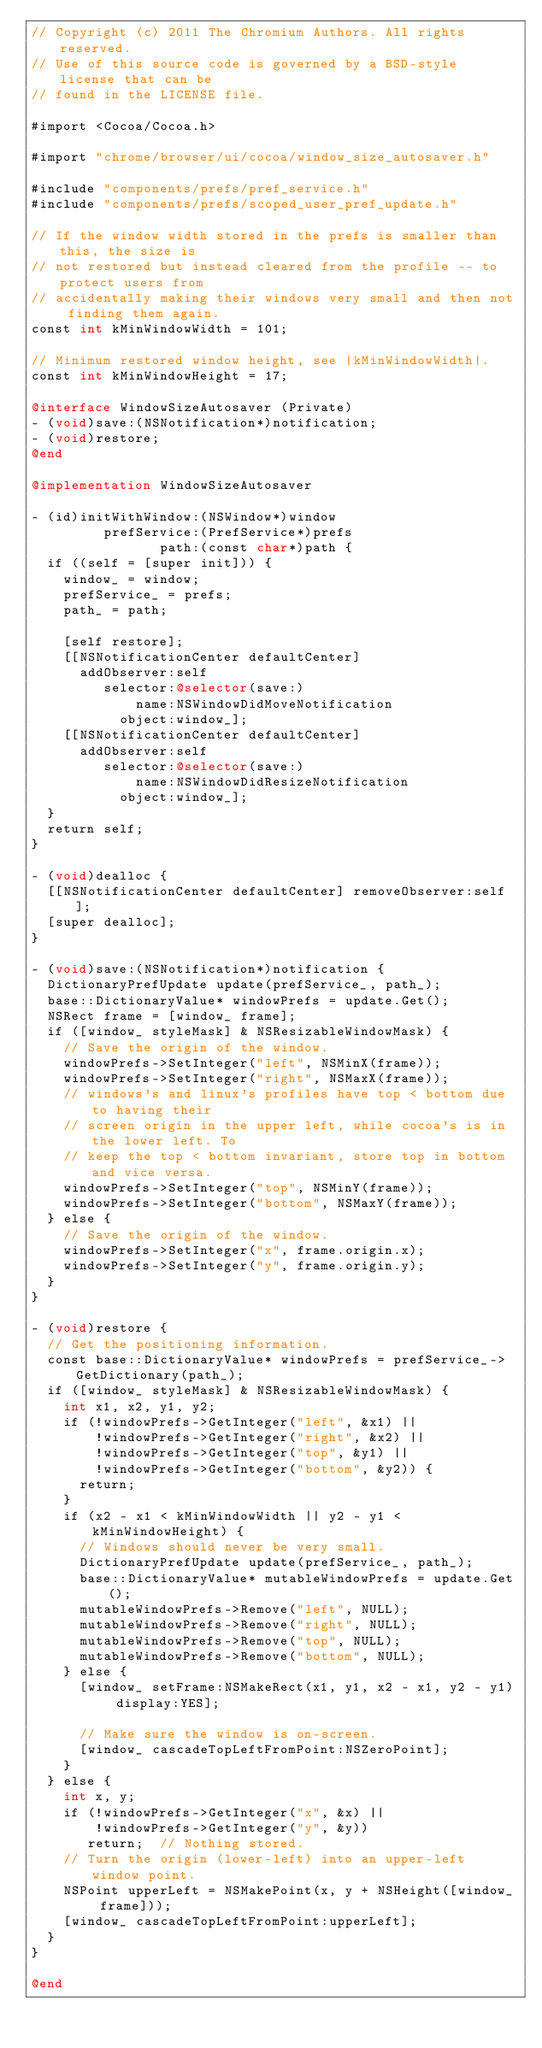<code> <loc_0><loc_0><loc_500><loc_500><_ObjectiveC_>// Copyright (c) 2011 The Chromium Authors. All rights reserved.
// Use of this source code is governed by a BSD-style license that can be
// found in the LICENSE file.

#import <Cocoa/Cocoa.h>

#import "chrome/browser/ui/cocoa/window_size_autosaver.h"

#include "components/prefs/pref_service.h"
#include "components/prefs/scoped_user_pref_update.h"

// If the window width stored in the prefs is smaller than this, the size is
// not restored but instead cleared from the profile -- to protect users from
// accidentally making their windows very small and then not finding them again.
const int kMinWindowWidth = 101;

// Minimum restored window height, see |kMinWindowWidth|.
const int kMinWindowHeight = 17;

@interface WindowSizeAutosaver (Private)
- (void)save:(NSNotification*)notification;
- (void)restore;
@end

@implementation WindowSizeAutosaver

- (id)initWithWindow:(NSWindow*)window
         prefService:(PrefService*)prefs
                path:(const char*)path {
  if ((self = [super init])) {
    window_ = window;
    prefService_ = prefs;
    path_ = path;

    [self restore];
    [[NSNotificationCenter defaultCenter]
      addObserver:self
         selector:@selector(save:)
             name:NSWindowDidMoveNotification
           object:window_];
    [[NSNotificationCenter defaultCenter]
      addObserver:self
         selector:@selector(save:)
             name:NSWindowDidResizeNotification
           object:window_];
  }
  return self;
}

- (void)dealloc {
  [[NSNotificationCenter defaultCenter] removeObserver:self];
  [super dealloc];
}

- (void)save:(NSNotification*)notification {
  DictionaryPrefUpdate update(prefService_, path_);
  base::DictionaryValue* windowPrefs = update.Get();
  NSRect frame = [window_ frame];
  if ([window_ styleMask] & NSResizableWindowMask) {
    // Save the origin of the window.
    windowPrefs->SetInteger("left", NSMinX(frame));
    windowPrefs->SetInteger("right", NSMaxX(frame));
    // windows's and linux's profiles have top < bottom due to having their
    // screen origin in the upper left, while cocoa's is in the lower left. To
    // keep the top < bottom invariant, store top in bottom and vice versa.
    windowPrefs->SetInteger("top", NSMinY(frame));
    windowPrefs->SetInteger("bottom", NSMaxY(frame));
  } else {
    // Save the origin of the window.
    windowPrefs->SetInteger("x", frame.origin.x);
    windowPrefs->SetInteger("y", frame.origin.y);
  }
}

- (void)restore {
  // Get the positioning information.
  const base::DictionaryValue* windowPrefs = prefService_->GetDictionary(path_);
  if ([window_ styleMask] & NSResizableWindowMask) {
    int x1, x2, y1, y2;
    if (!windowPrefs->GetInteger("left", &x1) ||
        !windowPrefs->GetInteger("right", &x2) ||
        !windowPrefs->GetInteger("top", &y1) ||
        !windowPrefs->GetInteger("bottom", &y2)) {
      return;
    }
    if (x2 - x1 < kMinWindowWidth || y2 - y1 < kMinWindowHeight) {
      // Windows should never be very small.
      DictionaryPrefUpdate update(prefService_, path_);
      base::DictionaryValue* mutableWindowPrefs = update.Get();
      mutableWindowPrefs->Remove("left", NULL);
      mutableWindowPrefs->Remove("right", NULL);
      mutableWindowPrefs->Remove("top", NULL);
      mutableWindowPrefs->Remove("bottom", NULL);
    } else {
      [window_ setFrame:NSMakeRect(x1, y1, x2 - x1, y2 - y1) display:YES];

      // Make sure the window is on-screen.
      [window_ cascadeTopLeftFromPoint:NSZeroPoint];
    }
  } else {
    int x, y;
    if (!windowPrefs->GetInteger("x", &x) ||
        !windowPrefs->GetInteger("y", &y))
       return;  // Nothing stored.
    // Turn the origin (lower-left) into an upper-left window point.
    NSPoint upperLeft = NSMakePoint(x, y + NSHeight([window_ frame]));
    [window_ cascadeTopLeftFromPoint:upperLeft];
  }
}

@end

</code> 